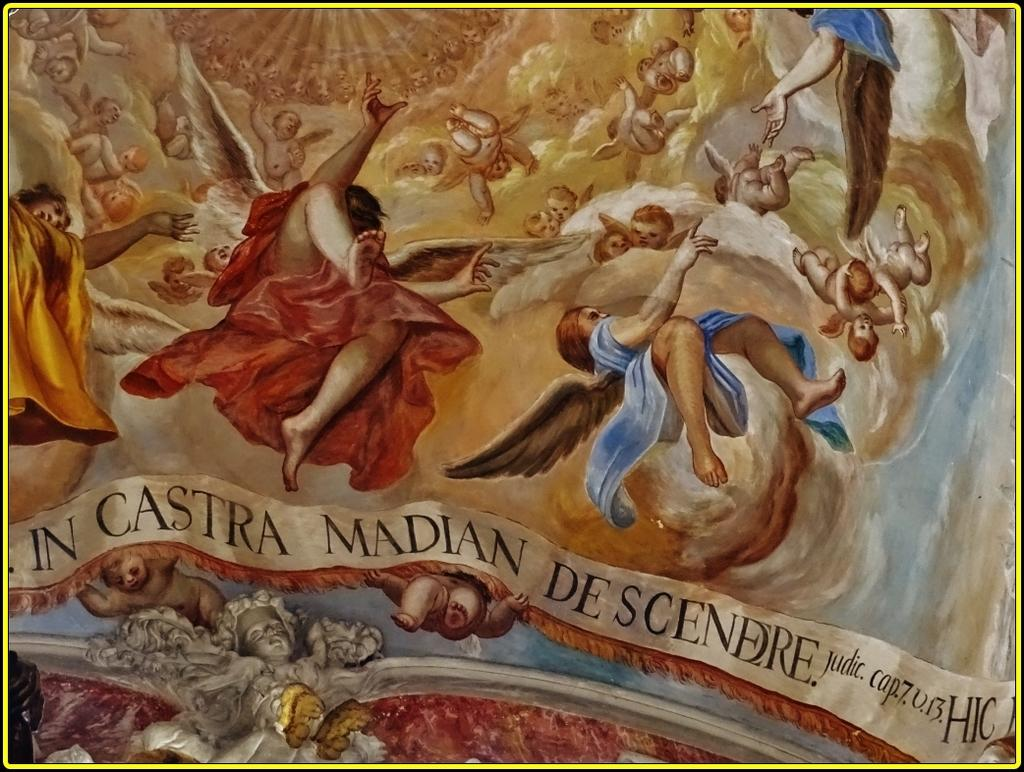Provide a one-sentence caption for the provided image. In Castra is written under the image if people falling. 